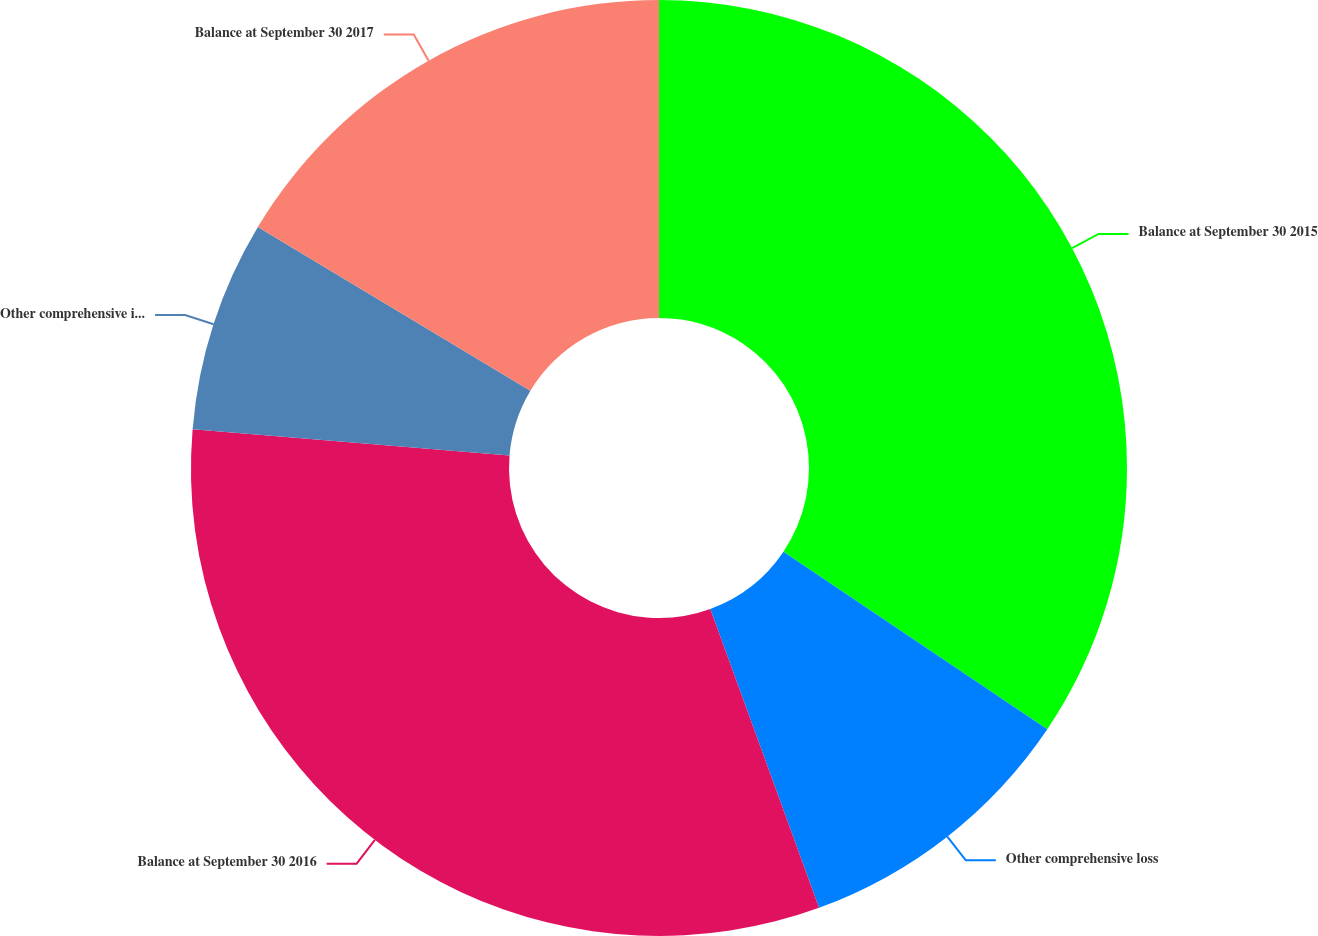<chart> <loc_0><loc_0><loc_500><loc_500><pie_chart><fcel>Balance at September 30 2015<fcel>Other comprehensive loss<fcel>Balance at September 30 2016<fcel>Other comprehensive income<fcel>Balance at September 30 2017<nl><fcel>34.43%<fcel>10.02%<fcel>31.88%<fcel>7.29%<fcel>16.39%<nl></chart> 